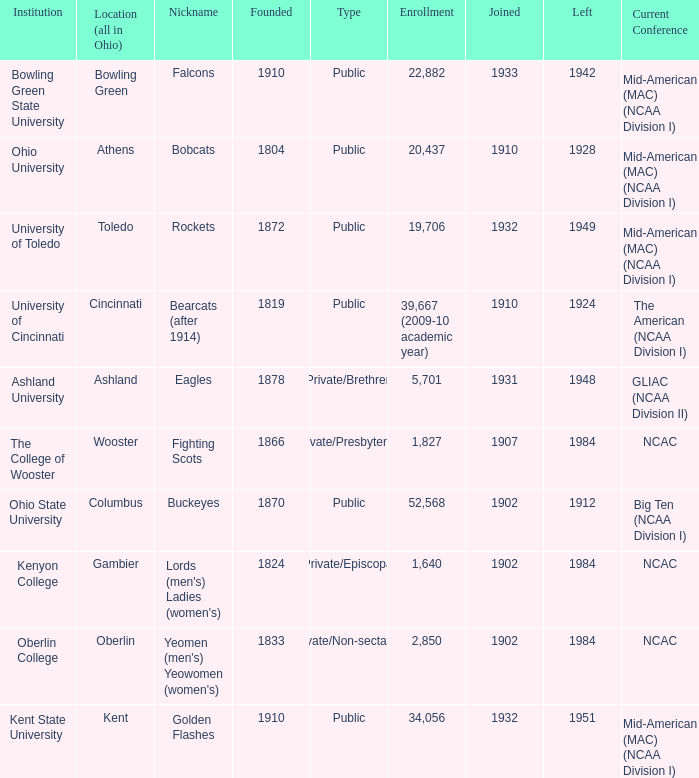Which year did enrolled Gambier members leave? 1984.0. Could you parse the entire table as a dict? {'header': ['Institution', 'Location (all in Ohio)', 'Nickname', 'Founded', 'Type', 'Enrollment', 'Joined', 'Left', 'Current Conference'], 'rows': [['Bowling Green State University', 'Bowling Green', 'Falcons', '1910', 'Public', '22,882', '1933', '1942', 'Mid-American (MAC) (NCAA Division I)'], ['Ohio University', 'Athens', 'Bobcats', '1804', 'Public', '20,437', '1910', '1928', 'Mid-American (MAC) (NCAA Division I)'], ['University of Toledo', 'Toledo', 'Rockets', '1872', 'Public', '19,706', '1932', '1949', 'Mid-American (MAC) (NCAA Division I)'], ['University of Cincinnati', 'Cincinnati', 'Bearcats (after 1914)', '1819', 'Public', '39,667 (2009-10 academic year)', '1910', '1924', 'The American (NCAA Division I)'], ['Ashland University', 'Ashland', 'Eagles', '1878', 'Private/Brethren', '5,701', '1931', '1948', 'GLIAC (NCAA Division II)'], ['The College of Wooster', 'Wooster', 'Fighting Scots', '1866', 'Private/Presbyterian', '1,827', '1907', '1984', 'NCAC'], ['Ohio State University', 'Columbus', 'Buckeyes', '1870', 'Public', '52,568', '1902', '1912', 'Big Ten (NCAA Division I)'], ['Kenyon College', 'Gambier', "Lords (men's) Ladies (women's)", '1824', 'Private/Episcopal', '1,640', '1902', '1984', 'NCAC'], ['Oberlin College', 'Oberlin', "Yeomen (men's) Yeowomen (women's)", '1833', 'Private/Non-sectarian', '2,850', '1902', '1984', 'NCAC'], ['Kent State University', 'Kent', 'Golden Flashes', '1910', 'Public', '34,056', '1932', '1951', 'Mid-American (MAC) (NCAA Division I)']]} 